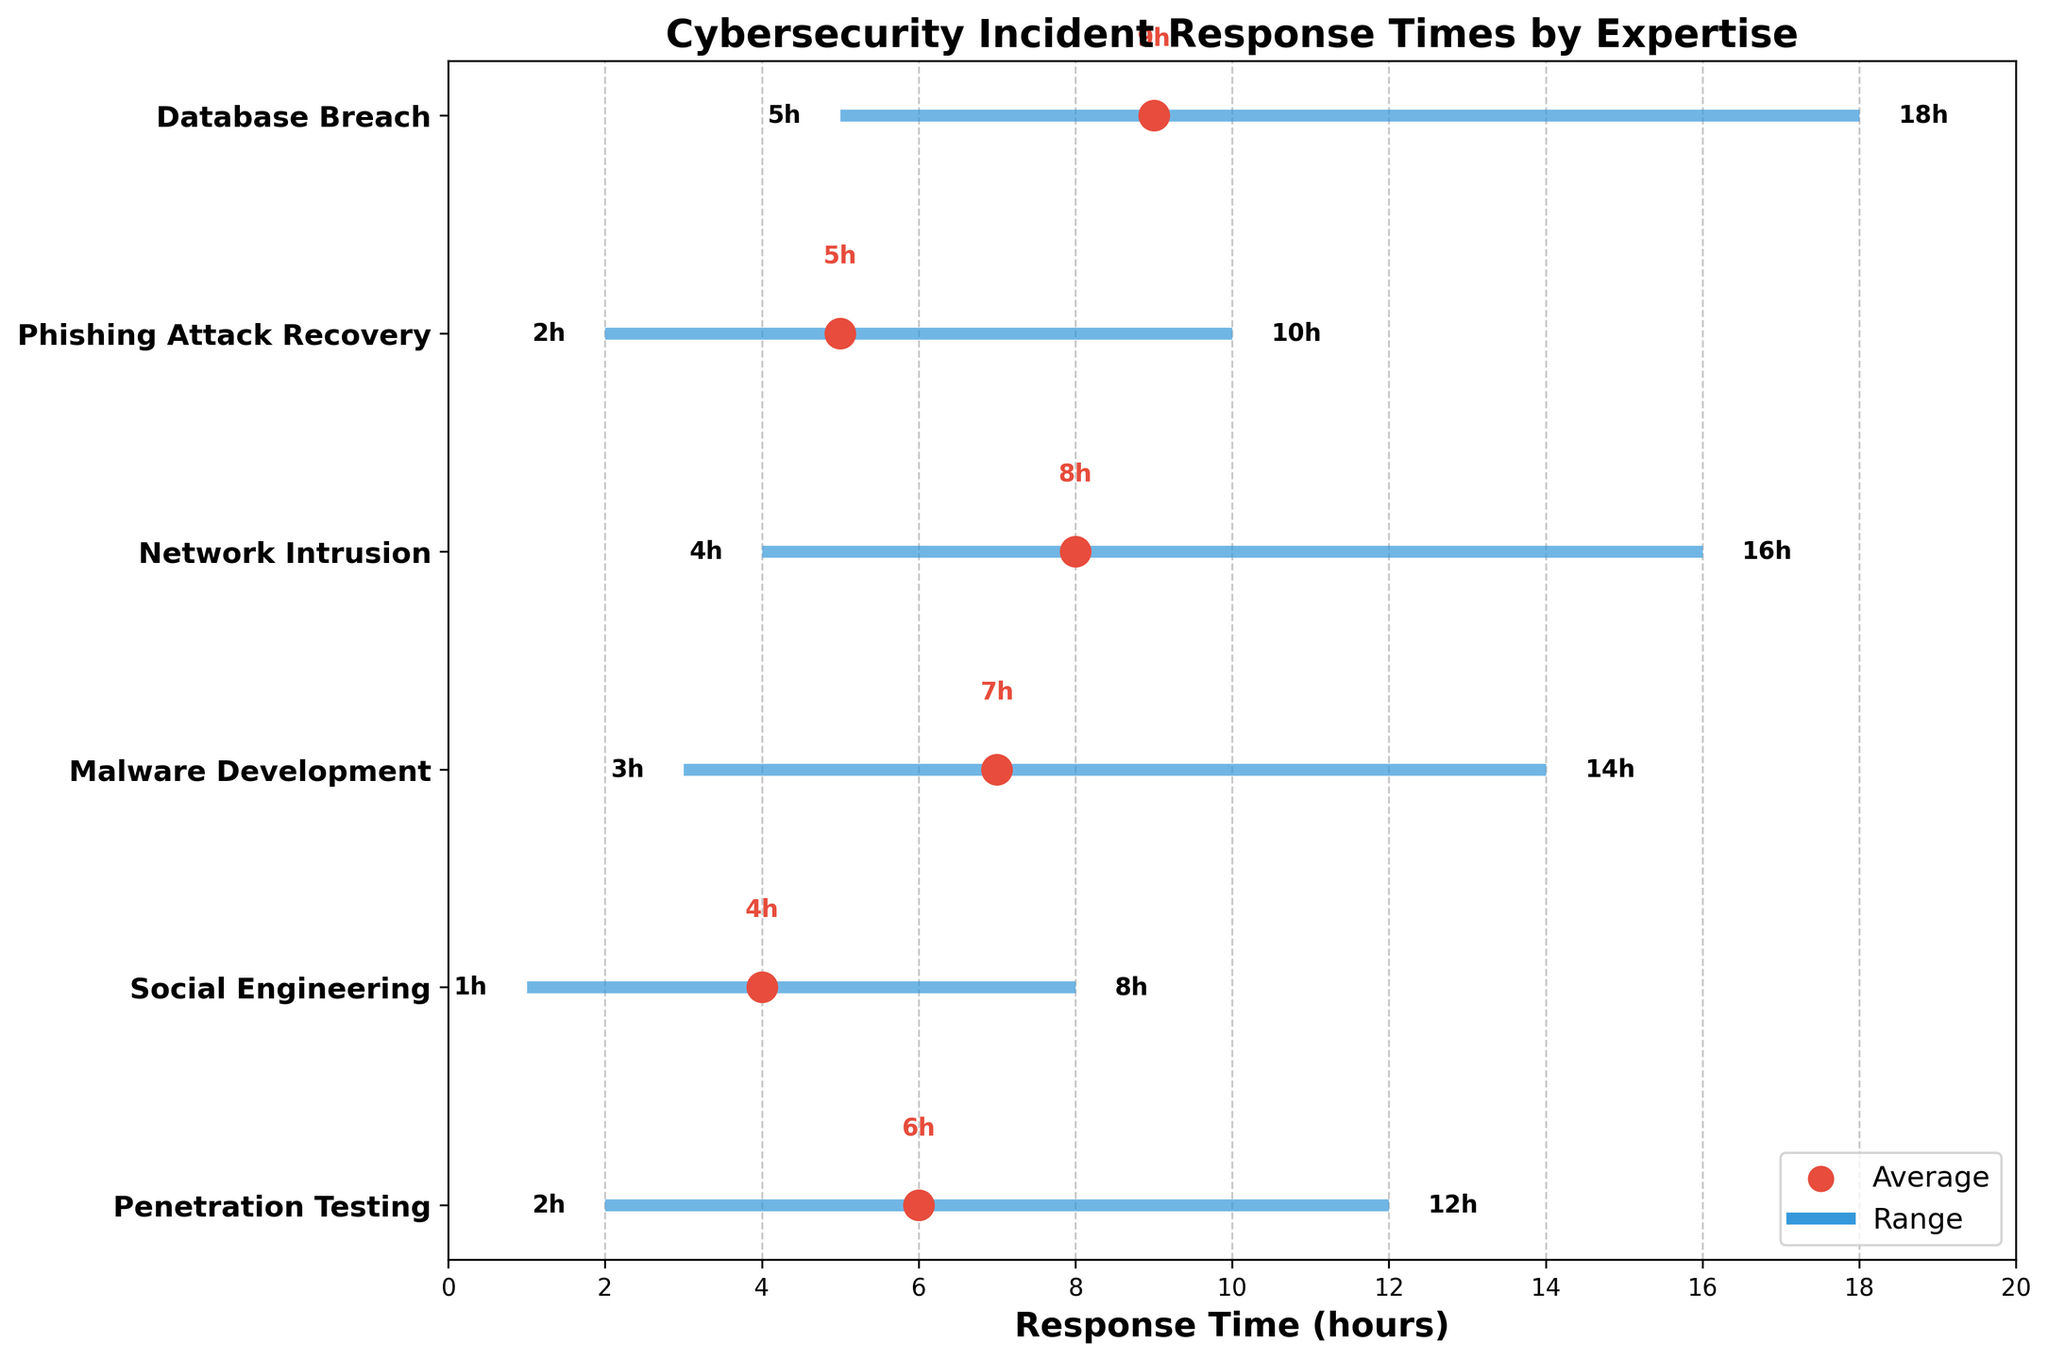How many types of expertise are displayed in the figure? Count the number of distinct expertise labels shown on the y-axis.
Answer: 6 What is the title of the figure? Look at the top of the figure where the title is typically placed.
Answer: Cybersecurity Incident Response Times by Expertise Which expertise has the shortest minimum response time? Identify the expertise with the smallest value on the left side of the plotted ranges.
Answer: Social Engineering What is the maximum response time for Network Intrusion? Find the maximum response time value on the right side for Network Intrusion.
Answer: 16 hours What is the average response time for Malware Development? Locate the red dot (representing the average response time) for Malware Development and note its value.
Answer: 7 hours What is the range of response times for Phishing Attack Recovery? Subtract the minimum response time from the maximum response time for Phishing Attack Recovery. The range is \(10 - 2\).
Answer: 8 hours Which expertise has the widest range of response times? Compare the ranges (maximum minus minimum) for each expertise and find the largest. The widest range is for Database Breach: \(18 - 5\).
Answer: Database Breach What is the difference between the average response times of Penetration Testing and Social Engineering? Subtract the average response time of Social Engineering from Penetration Testing: \(6 - 4\).
Answer: 2 hours Does any expertise have the same minimum and maximum response times? Check if there are any expertise with the same minimum and maximum values; if the range is zero, it means they are the same.
Answer: No Which expertise has the most centered average response time within its range? Look for the expertise whose average is closest to the midpoint of its minimum and maximum response times. Calculate the midpoints and see which average is closest. For Phishing Attack Recovery, midpoint \( \frac{(10 + 2)}{2} = 6 \). The average is also 5, so it is the most centered.
Answer: Phishing Attack Recovery 